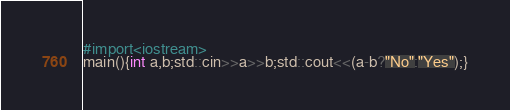<code> <loc_0><loc_0><loc_500><loc_500><_C++_>#import<iostream>
main(){int a,b;std::cin>>a>>b;std::cout<<(a-b?"No":"Yes");}</code> 